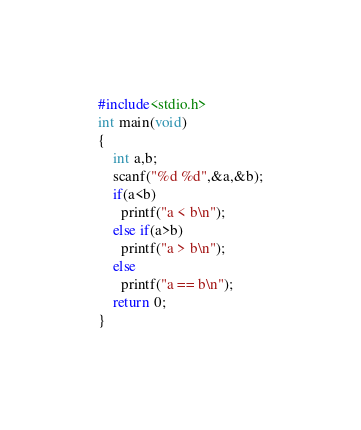Convert code to text. <code><loc_0><loc_0><loc_500><loc_500><_C_>#include<stdio.h>
int main(void)
{
    int a,b;
    scanf("%d %d",&a,&b);
    if(a<b)
      printf("a < b\n");
    else if(a>b)
      printf("a > b\n");
    else
      printf("a == b\n");
    return 0;
}

</code> 